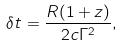Convert formula to latex. <formula><loc_0><loc_0><loc_500><loc_500>\delta t = \frac { R ( 1 + z ) } { 2 c \Gamma ^ { 2 } } ,</formula> 